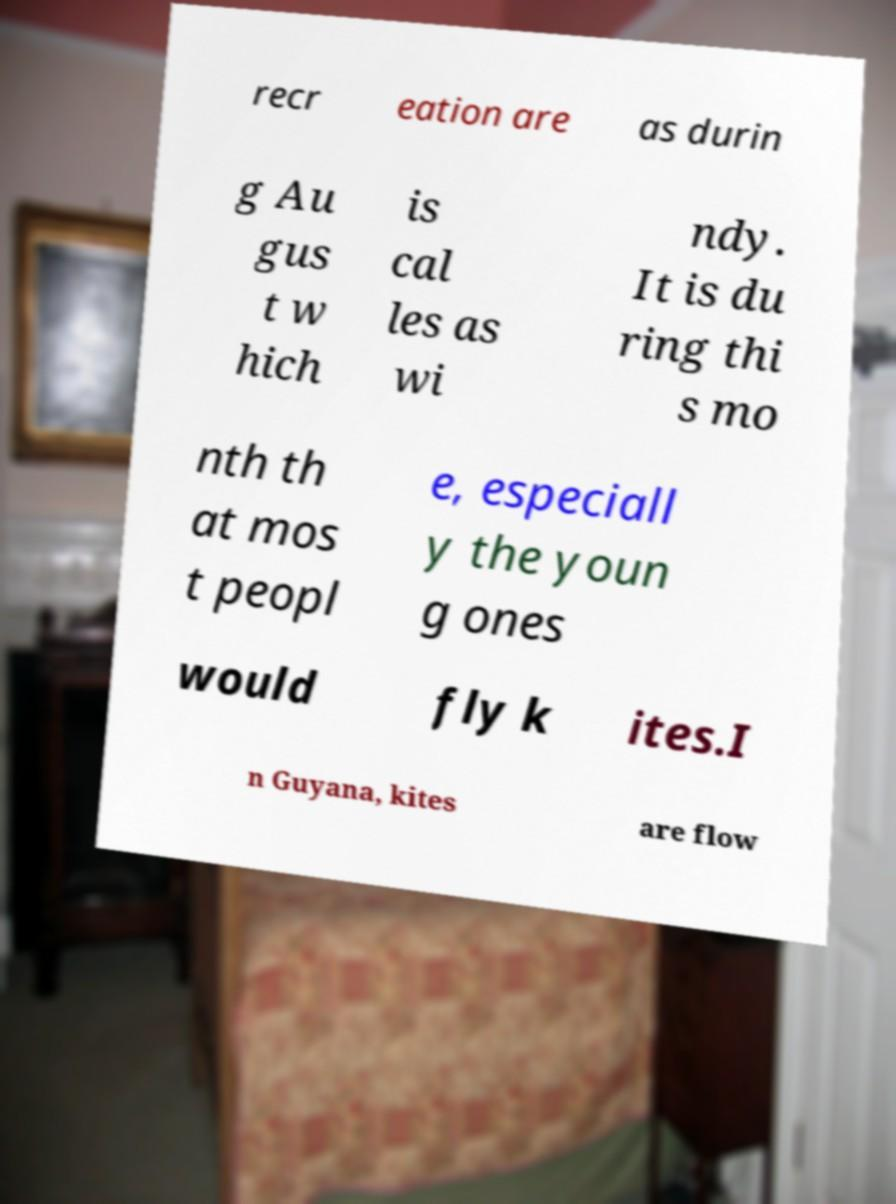Could you extract and type out the text from this image? recr eation are as durin g Au gus t w hich is cal les as wi ndy. It is du ring thi s mo nth th at mos t peopl e, especiall y the youn g ones would fly k ites.I n Guyana, kites are flow 